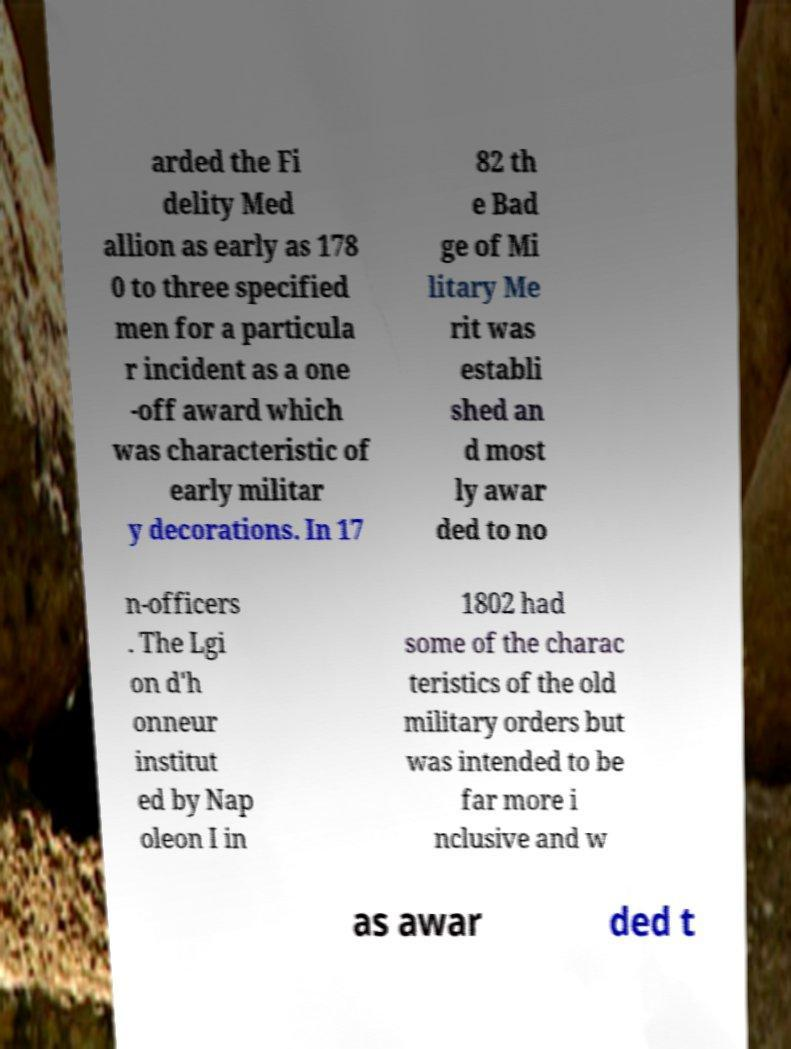Please read and relay the text visible in this image. What does it say? arded the Fi delity Med allion as early as 178 0 to three specified men for a particula r incident as a one -off award which was characteristic of early militar y decorations. In 17 82 th e Bad ge of Mi litary Me rit was establi shed an d most ly awar ded to no n-officers . The Lgi on d'h onneur institut ed by Nap oleon I in 1802 had some of the charac teristics of the old military orders but was intended to be far more i nclusive and w as awar ded t 